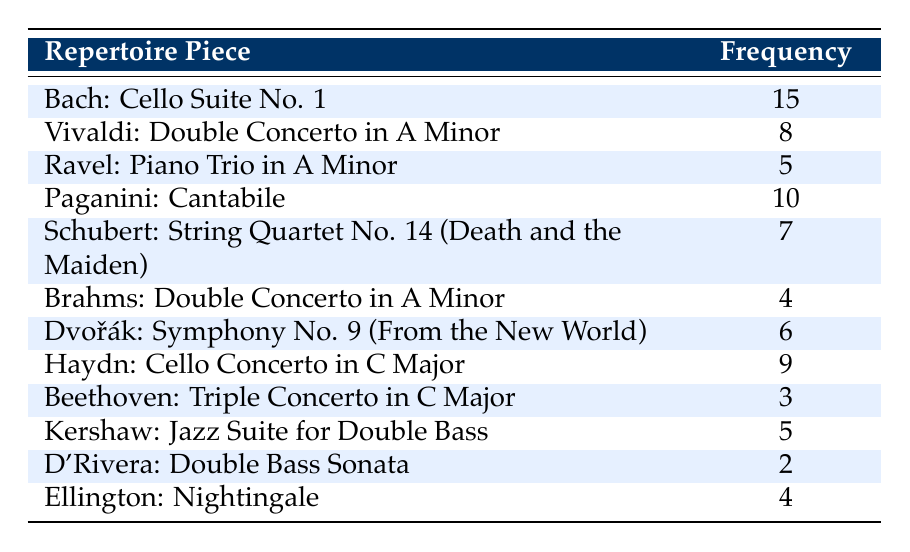What is the piece with the highest frequency? Looking at the "Frequency" column, the highest frequency is 15, which corresponds to "Bach: Cello Suite No. 1."
Answer: Bach: Cello Suite No. 1 How many pieces are played 5 times? By scanning through the "Frequency" column, we can see that "Ravel: Piano Trio in A Minor" and "Kershaw: Jazz Suite for Double Bass" both have a frequency of 5. Thus, there are 2 pieces played 5 times.
Answer: 2 Is "Ellington: Nightingale" played more frequently than "Beethoven: Triple Concerto in C Major"? "Ellington: Nightingale" has a frequency of 4 while "Beethoven: Triple Concerto in C Major" has a frequency of 3. Since 4 is greater than 3, the statement is true.
Answer: Yes What is the total frequency of pieces by composers whose last name starts with 'D'? The relevant pieces are "Dvořák: Symphony No. 9" with a frequency of 6 and "D'Rivera: Double Bass Sonata" with a frequency of 2. Adding these gives 6 + 2 = 8.
Answer: 8 Which composer has the least played piece? From the table, "D'Rivera: Double Bass Sonata" with a frequency of 2 is the least played piece, as it has the lowest frequency.
Answer: D'Rivera: Double Bass Sonata How many more times is "Haydn: Cello Concerto in C Major" played compared to "Brahms: Double Concerto in A Minor"? "Haydn: Cello Concerto in C Major" is played 9 times, while "Brahms: Double Concerto in A Minor" is played 4 times. The difference is 9 - 4 = 5.
Answer: 5 What is the average frequency of the repertoire pieces in this table? To find the average, we first sum all frequencies: (15 + 8 + 5 + 10 + 7 + 4 + 6 + 9 + 3 + 5 + 2 + 4) = 73. There are 12 pieces, so the average frequency is 73/12 ≈ 6.08.
Answer: 6.08 Are there any pieces that are played 10 or more times? Checking the table, "Bach: Cello Suite No. 1" is played 15 times and "Paganini: Cantabile" is played 10 times. So, there are two pieces that meet this condition.
Answer: Yes Which piece is the most popular after "Bach: Cello Suite No. 1"? After "Bach: Cello Suite No. 1" with 15, the next highest frequency is "Paganini: Cantabile" with a frequency of 10.
Answer: Paganini: Cantabile 